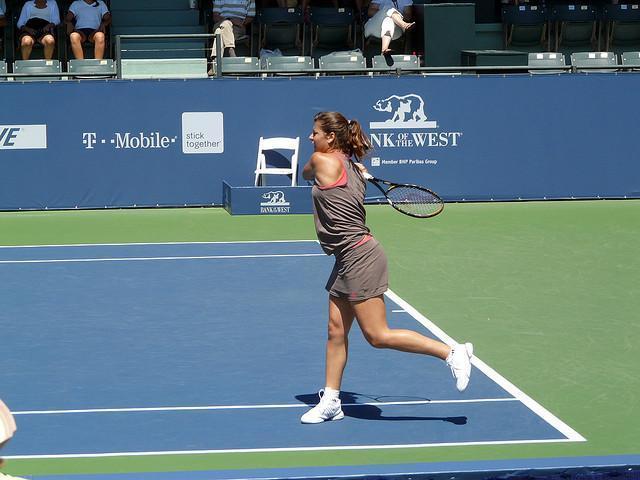How many tennis rackets are visible?
Give a very brief answer. 1. 